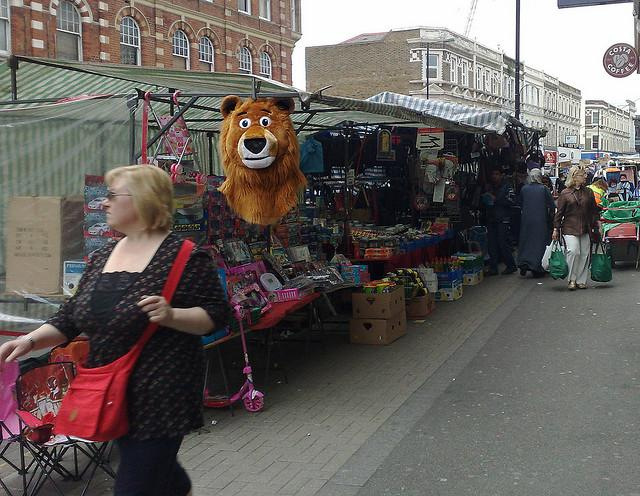Why are there stalls with products outside?

Choices:
A) for homeless
B) to decorate
C) to sell
D) for fundraising to sell 